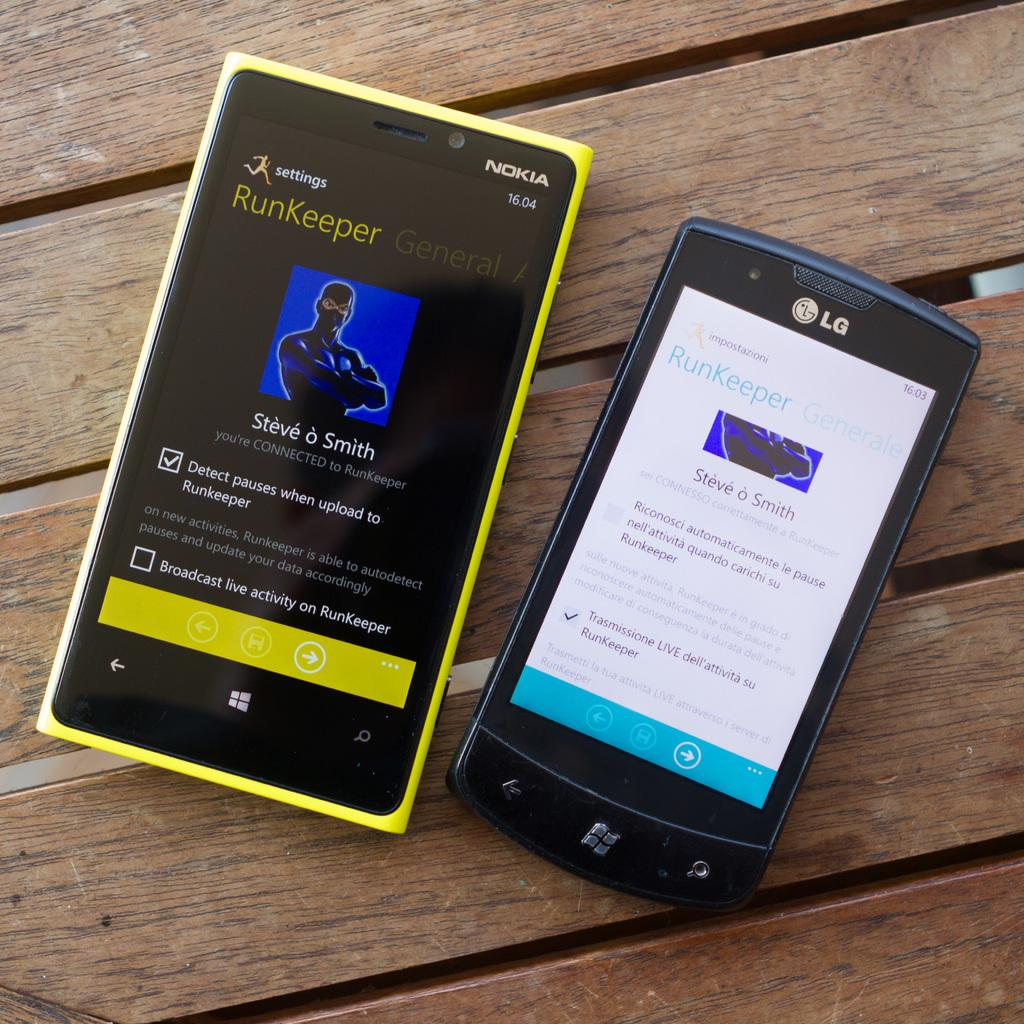Provide a one-sentence caption for the provided image. Nokia and LG phones display the RunKeeper app. 